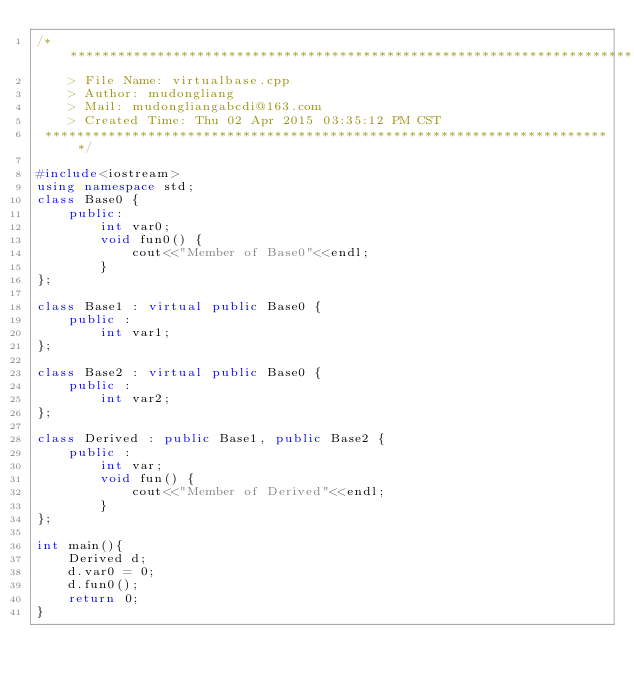<code> <loc_0><loc_0><loc_500><loc_500><_C++_>/*************************************************************************
	> File Name: virtualbase.cpp
	> Author: mudongliang
	> Mail: mudongliangabcdi@163.com
	> Created Time: Thu 02 Apr 2015 03:35:12 PM CST
 ************************************************************************/

#include<iostream>
using namespace std;
class Base0 {
	public:
		int var0;
		void fun0() {
			cout<<"Member of Base0"<<endl;
		}
};

class Base1 : virtual public Base0 {
	public :
		int var1;
};

class Base2 : virtual public Base0 {
	public :
		int var2;
};

class Derived : public Base1, public Base2 {
	public :
		int var;
		void fun() {
			cout<<"Member of Derived"<<endl;
		}
};

int main(){ 
	Derived d;
	d.var0 = 0;
	d.fun0();
    return 0;
}
</code> 